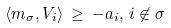<formula> <loc_0><loc_0><loc_500><loc_500>\langle m _ { \sigma } , V _ { i } \rangle \, \geq \, - a _ { i } , \, i \not \in \sigma</formula> 